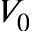Convert formula to latex. <formula><loc_0><loc_0><loc_500><loc_500>V _ { 0 }</formula> 